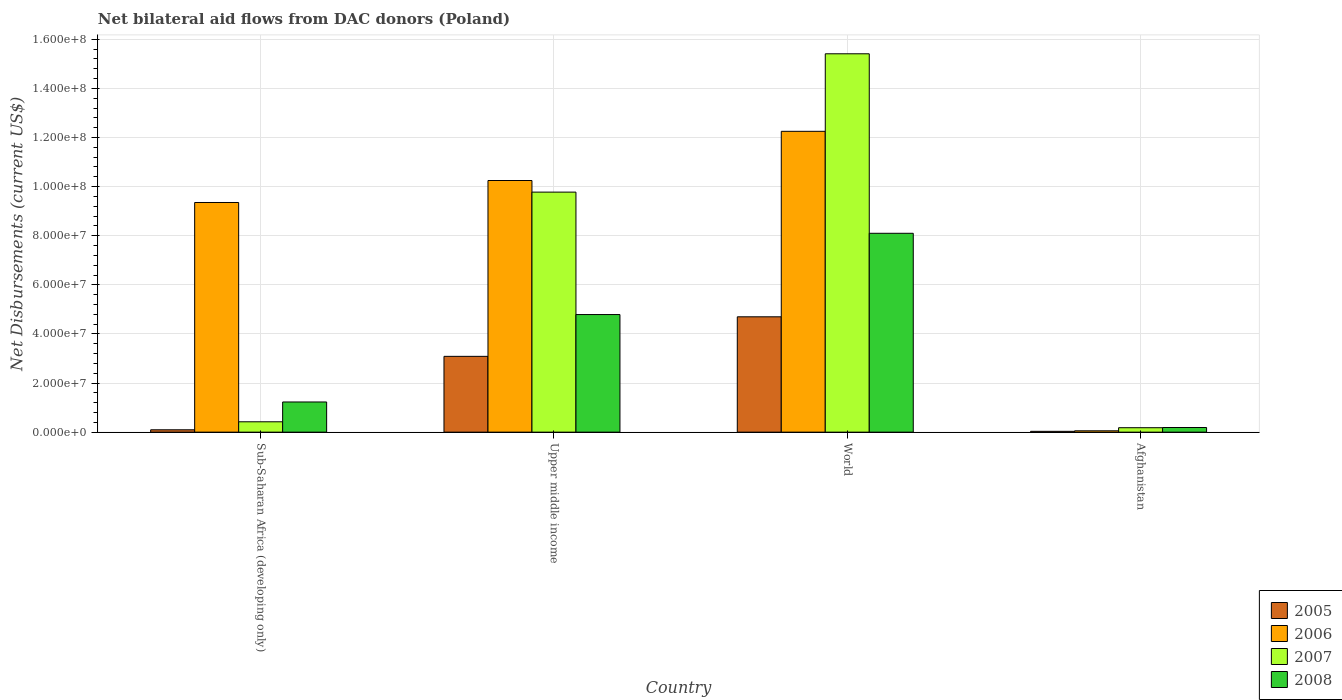How many different coloured bars are there?
Provide a short and direct response. 4. How many groups of bars are there?
Give a very brief answer. 4. Are the number of bars per tick equal to the number of legend labels?
Your response must be concise. Yes. Are the number of bars on each tick of the X-axis equal?
Ensure brevity in your answer.  Yes. What is the label of the 2nd group of bars from the left?
Offer a very short reply. Upper middle income. In how many cases, is the number of bars for a given country not equal to the number of legend labels?
Provide a succinct answer. 0. What is the net bilateral aid flows in 2008 in Afghanistan?
Give a very brief answer. 1.89e+06. Across all countries, what is the maximum net bilateral aid flows in 2008?
Offer a very short reply. 8.10e+07. Across all countries, what is the minimum net bilateral aid flows in 2007?
Your answer should be very brief. 1.81e+06. In which country was the net bilateral aid flows in 2007 minimum?
Keep it short and to the point. Afghanistan. What is the total net bilateral aid flows in 2005 in the graph?
Your answer should be compact. 7.91e+07. What is the difference between the net bilateral aid flows in 2007 in Upper middle income and that in World?
Keep it short and to the point. -5.63e+07. What is the difference between the net bilateral aid flows in 2008 in Upper middle income and the net bilateral aid flows in 2006 in Sub-Saharan Africa (developing only)?
Offer a terse response. -4.56e+07. What is the average net bilateral aid flows in 2008 per country?
Offer a very short reply. 3.58e+07. What is the difference between the net bilateral aid flows of/in 2005 and net bilateral aid flows of/in 2007 in Upper middle income?
Give a very brief answer. -6.69e+07. What is the ratio of the net bilateral aid flows in 2006 in Sub-Saharan Africa (developing only) to that in Upper middle income?
Keep it short and to the point. 0.91. Is the difference between the net bilateral aid flows in 2005 in Sub-Saharan Africa (developing only) and Upper middle income greater than the difference between the net bilateral aid flows in 2007 in Sub-Saharan Africa (developing only) and Upper middle income?
Offer a very short reply. Yes. What is the difference between the highest and the second highest net bilateral aid flows in 2008?
Make the answer very short. 3.31e+07. What is the difference between the highest and the lowest net bilateral aid flows in 2007?
Your answer should be very brief. 1.52e+08. Is the sum of the net bilateral aid flows in 2005 in Upper middle income and World greater than the maximum net bilateral aid flows in 2008 across all countries?
Give a very brief answer. No. What does the 3rd bar from the right in Sub-Saharan Africa (developing only) represents?
Your answer should be very brief. 2006. Is it the case that in every country, the sum of the net bilateral aid flows in 2007 and net bilateral aid flows in 2006 is greater than the net bilateral aid flows in 2008?
Offer a terse response. Yes. Are all the bars in the graph horizontal?
Your response must be concise. No. What is the difference between two consecutive major ticks on the Y-axis?
Make the answer very short. 2.00e+07. Are the values on the major ticks of Y-axis written in scientific E-notation?
Give a very brief answer. Yes. Does the graph contain grids?
Your answer should be compact. Yes. Where does the legend appear in the graph?
Give a very brief answer. Bottom right. How many legend labels are there?
Your answer should be very brief. 4. What is the title of the graph?
Ensure brevity in your answer.  Net bilateral aid flows from DAC donors (Poland). Does "1984" appear as one of the legend labels in the graph?
Provide a succinct answer. No. What is the label or title of the Y-axis?
Offer a very short reply. Net Disbursements (current US$). What is the Net Disbursements (current US$) in 2005 in Sub-Saharan Africa (developing only)?
Ensure brevity in your answer.  9.60e+05. What is the Net Disbursements (current US$) of 2006 in Sub-Saharan Africa (developing only)?
Offer a very short reply. 9.35e+07. What is the Net Disbursements (current US$) in 2007 in Sub-Saharan Africa (developing only)?
Your answer should be compact. 4.22e+06. What is the Net Disbursements (current US$) in 2008 in Sub-Saharan Africa (developing only)?
Offer a terse response. 1.23e+07. What is the Net Disbursements (current US$) of 2005 in Upper middle income?
Provide a short and direct response. 3.09e+07. What is the Net Disbursements (current US$) of 2006 in Upper middle income?
Make the answer very short. 1.02e+08. What is the Net Disbursements (current US$) in 2007 in Upper middle income?
Provide a succinct answer. 9.78e+07. What is the Net Disbursements (current US$) in 2008 in Upper middle income?
Provide a succinct answer. 4.79e+07. What is the Net Disbursements (current US$) in 2005 in World?
Your answer should be very brief. 4.70e+07. What is the Net Disbursements (current US$) in 2006 in World?
Give a very brief answer. 1.23e+08. What is the Net Disbursements (current US$) of 2007 in World?
Your answer should be very brief. 1.54e+08. What is the Net Disbursements (current US$) of 2008 in World?
Offer a terse response. 8.10e+07. What is the Net Disbursements (current US$) in 2007 in Afghanistan?
Offer a very short reply. 1.81e+06. What is the Net Disbursements (current US$) of 2008 in Afghanistan?
Make the answer very short. 1.89e+06. Across all countries, what is the maximum Net Disbursements (current US$) in 2005?
Make the answer very short. 4.70e+07. Across all countries, what is the maximum Net Disbursements (current US$) of 2006?
Keep it short and to the point. 1.23e+08. Across all countries, what is the maximum Net Disbursements (current US$) in 2007?
Your answer should be very brief. 1.54e+08. Across all countries, what is the maximum Net Disbursements (current US$) in 2008?
Provide a succinct answer. 8.10e+07. Across all countries, what is the minimum Net Disbursements (current US$) of 2005?
Your answer should be compact. 3.30e+05. Across all countries, what is the minimum Net Disbursements (current US$) in 2006?
Provide a succinct answer. 5.50e+05. Across all countries, what is the minimum Net Disbursements (current US$) in 2007?
Offer a terse response. 1.81e+06. Across all countries, what is the minimum Net Disbursements (current US$) of 2008?
Provide a short and direct response. 1.89e+06. What is the total Net Disbursements (current US$) of 2005 in the graph?
Provide a short and direct response. 7.91e+07. What is the total Net Disbursements (current US$) in 2006 in the graph?
Provide a short and direct response. 3.19e+08. What is the total Net Disbursements (current US$) in 2007 in the graph?
Your answer should be very brief. 2.58e+08. What is the total Net Disbursements (current US$) in 2008 in the graph?
Offer a terse response. 1.43e+08. What is the difference between the Net Disbursements (current US$) of 2005 in Sub-Saharan Africa (developing only) and that in Upper middle income?
Your answer should be very brief. -2.99e+07. What is the difference between the Net Disbursements (current US$) in 2006 in Sub-Saharan Africa (developing only) and that in Upper middle income?
Offer a very short reply. -8.96e+06. What is the difference between the Net Disbursements (current US$) of 2007 in Sub-Saharan Africa (developing only) and that in Upper middle income?
Your response must be concise. -9.36e+07. What is the difference between the Net Disbursements (current US$) of 2008 in Sub-Saharan Africa (developing only) and that in Upper middle income?
Give a very brief answer. -3.56e+07. What is the difference between the Net Disbursements (current US$) in 2005 in Sub-Saharan Africa (developing only) and that in World?
Give a very brief answer. -4.60e+07. What is the difference between the Net Disbursements (current US$) of 2006 in Sub-Saharan Africa (developing only) and that in World?
Provide a succinct answer. -2.90e+07. What is the difference between the Net Disbursements (current US$) in 2007 in Sub-Saharan Africa (developing only) and that in World?
Provide a short and direct response. -1.50e+08. What is the difference between the Net Disbursements (current US$) in 2008 in Sub-Saharan Africa (developing only) and that in World?
Keep it short and to the point. -6.87e+07. What is the difference between the Net Disbursements (current US$) of 2005 in Sub-Saharan Africa (developing only) and that in Afghanistan?
Offer a very short reply. 6.30e+05. What is the difference between the Net Disbursements (current US$) in 2006 in Sub-Saharan Africa (developing only) and that in Afghanistan?
Your response must be concise. 9.30e+07. What is the difference between the Net Disbursements (current US$) of 2007 in Sub-Saharan Africa (developing only) and that in Afghanistan?
Give a very brief answer. 2.41e+06. What is the difference between the Net Disbursements (current US$) of 2008 in Sub-Saharan Africa (developing only) and that in Afghanistan?
Offer a very short reply. 1.04e+07. What is the difference between the Net Disbursements (current US$) of 2005 in Upper middle income and that in World?
Offer a terse response. -1.61e+07. What is the difference between the Net Disbursements (current US$) in 2006 in Upper middle income and that in World?
Give a very brief answer. -2.00e+07. What is the difference between the Net Disbursements (current US$) of 2007 in Upper middle income and that in World?
Make the answer very short. -5.63e+07. What is the difference between the Net Disbursements (current US$) of 2008 in Upper middle income and that in World?
Keep it short and to the point. -3.31e+07. What is the difference between the Net Disbursements (current US$) of 2005 in Upper middle income and that in Afghanistan?
Provide a short and direct response. 3.05e+07. What is the difference between the Net Disbursements (current US$) of 2006 in Upper middle income and that in Afghanistan?
Ensure brevity in your answer.  1.02e+08. What is the difference between the Net Disbursements (current US$) of 2007 in Upper middle income and that in Afghanistan?
Offer a very short reply. 9.60e+07. What is the difference between the Net Disbursements (current US$) of 2008 in Upper middle income and that in Afghanistan?
Offer a terse response. 4.60e+07. What is the difference between the Net Disbursements (current US$) in 2005 in World and that in Afghanistan?
Your response must be concise. 4.66e+07. What is the difference between the Net Disbursements (current US$) in 2006 in World and that in Afghanistan?
Make the answer very short. 1.22e+08. What is the difference between the Net Disbursements (current US$) of 2007 in World and that in Afghanistan?
Your answer should be very brief. 1.52e+08. What is the difference between the Net Disbursements (current US$) in 2008 in World and that in Afghanistan?
Provide a short and direct response. 7.91e+07. What is the difference between the Net Disbursements (current US$) of 2005 in Sub-Saharan Africa (developing only) and the Net Disbursements (current US$) of 2006 in Upper middle income?
Make the answer very short. -1.02e+08. What is the difference between the Net Disbursements (current US$) of 2005 in Sub-Saharan Africa (developing only) and the Net Disbursements (current US$) of 2007 in Upper middle income?
Offer a terse response. -9.68e+07. What is the difference between the Net Disbursements (current US$) of 2005 in Sub-Saharan Africa (developing only) and the Net Disbursements (current US$) of 2008 in Upper middle income?
Make the answer very short. -4.69e+07. What is the difference between the Net Disbursements (current US$) in 2006 in Sub-Saharan Africa (developing only) and the Net Disbursements (current US$) in 2007 in Upper middle income?
Provide a succinct answer. -4.23e+06. What is the difference between the Net Disbursements (current US$) of 2006 in Sub-Saharan Africa (developing only) and the Net Disbursements (current US$) of 2008 in Upper middle income?
Ensure brevity in your answer.  4.56e+07. What is the difference between the Net Disbursements (current US$) in 2007 in Sub-Saharan Africa (developing only) and the Net Disbursements (current US$) in 2008 in Upper middle income?
Make the answer very short. -4.37e+07. What is the difference between the Net Disbursements (current US$) of 2005 in Sub-Saharan Africa (developing only) and the Net Disbursements (current US$) of 2006 in World?
Your response must be concise. -1.22e+08. What is the difference between the Net Disbursements (current US$) of 2005 in Sub-Saharan Africa (developing only) and the Net Disbursements (current US$) of 2007 in World?
Give a very brief answer. -1.53e+08. What is the difference between the Net Disbursements (current US$) in 2005 in Sub-Saharan Africa (developing only) and the Net Disbursements (current US$) in 2008 in World?
Provide a short and direct response. -8.00e+07. What is the difference between the Net Disbursements (current US$) of 2006 in Sub-Saharan Africa (developing only) and the Net Disbursements (current US$) of 2007 in World?
Your response must be concise. -6.06e+07. What is the difference between the Net Disbursements (current US$) of 2006 in Sub-Saharan Africa (developing only) and the Net Disbursements (current US$) of 2008 in World?
Provide a short and direct response. 1.25e+07. What is the difference between the Net Disbursements (current US$) of 2007 in Sub-Saharan Africa (developing only) and the Net Disbursements (current US$) of 2008 in World?
Offer a very short reply. -7.68e+07. What is the difference between the Net Disbursements (current US$) of 2005 in Sub-Saharan Africa (developing only) and the Net Disbursements (current US$) of 2006 in Afghanistan?
Make the answer very short. 4.10e+05. What is the difference between the Net Disbursements (current US$) in 2005 in Sub-Saharan Africa (developing only) and the Net Disbursements (current US$) in 2007 in Afghanistan?
Give a very brief answer. -8.50e+05. What is the difference between the Net Disbursements (current US$) in 2005 in Sub-Saharan Africa (developing only) and the Net Disbursements (current US$) in 2008 in Afghanistan?
Make the answer very short. -9.30e+05. What is the difference between the Net Disbursements (current US$) in 2006 in Sub-Saharan Africa (developing only) and the Net Disbursements (current US$) in 2007 in Afghanistan?
Give a very brief answer. 9.17e+07. What is the difference between the Net Disbursements (current US$) in 2006 in Sub-Saharan Africa (developing only) and the Net Disbursements (current US$) in 2008 in Afghanistan?
Offer a terse response. 9.16e+07. What is the difference between the Net Disbursements (current US$) of 2007 in Sub-Saharan Africa (developing only) and the Net Disbursements (current US$) of 2008 in Afghanistan?
Your answer should be very brief. 2.33e+06. What is the difference between the Net Disbursements (current US$) in 2005 in Upper middle income and the Net Disbursements (current US$) in 2006 in World?
Provide a succinct answer. -9.17e+07. What is the difference between the Net Disbursements (current US$) of 2005 in Upper middle income and the Net Disbursements (current US$) of 2007 in World?
Offer a very short reply. -1.23e+08. What is the difference between the Net Disbursements (current US$) in 2005 in Upper middle income and the Net Disbursements (current US$) in 2008 in World?
Provide a succinct answer. -5.01e+07. What is the difference between the Net Disbursements (current US$) of 2006 in Upper middle income and the Net Disbursements (current US$) of 2007 in World?
Keep it short and to the point. -5.16e+07. What is the difference between the Net Disbursements (current US$) of 2006 in Upper middle income and the Net Disbursements (current US$) of 2008 in World?
Ensure brevity in your answer.  2.15e+07. What is the difference between the Net Disbursements (current US$) in 2007 in Upper middle income and the Net Disbursements (current US$) in 2008 in World?
Make the answer very short. 1.68e+07. What is the difference between the Net Disbursements (current US$) in 2005 in Upper middle income and the Net Disbursements (current US$) in 2006 in Afghanistan?
Ensure brevity in your answer.  3.03e+07. What is the difference between the Net Disbursements (current US$) of 2005 in Upper middle income and the Net Disbursements (current US$) of 2007 in Afghanistan?
Offer a terse response. 2.91e+07. What is the difference between the Net Disbursements (current US$) of 2005 in Upper middle income and the Net Disbursements (current US$) of 2008 in Afghanistan?
Make the answer very short. 2.90e+07. What is the difference between the Net Disbursements (current US$) of 2006 in Upper middle income and the Net Disbursements (current US$) of 2007 in Afghanistan?
Ensure brevity in your answer.  1.01e+08. What is the difference between the Net Disbursements (current US$) in 2006 in Upper middle income and the Net Disbursements (current US$) in 2008 in Afghanistan?
Offer a terse response. 1.01e+08. What is the difference between the Net Disbursements (current US$) of 2007 in Upper middle income and the Net Disbursements (current US$) of 2008 in Afghanistan?
Offer a terse response. 9.59e+07. What is the difference between the Net Disbursements (current US$) of 2005 in World and the Net Disbursements (current US$) of 2006 in Afghanistan?
Keep it short and to the point. 4.64e+07. What is the difference between the Net Disbursements (current US$) of 2005 in World and the Net Disbursements (current US$) of 2007 in Afghanistan?
Offer a terse response. 4.52e+07. What is the difference between the Net Disbursements (current US$) in 2005 in World and the Net Disbursements (current US$) in 2008 in Afghanistan?
Give a very brief answer. 4.51e+07. What is the difference between the Net Disbursements (current US$) of 2006 in World and the Net Disbursements (current US$) of 2007 in Afghanistan?
Keep it short and to the point. 1.21e+08. What is the difference between the Net Disbursements (current US$) of 2006 in World and the Net Disbursements (current US$) of 2008 in Afghanistan?
Give a very brief answer. 1.21e+08. What is the difference between the Net Disbursements (current US$) of 2007 in World and the Net Disbursements (current US$) of 2008 in Afghanistan?
Provide a succinct answer. 1.52e+08. What is the average Net Disbursements (current US$) of 2005 per country?
Keep it short and to the point. 1.98e+07. What is the average Net Disbursements (current US$) of 2006 per country?
Keep it short and to the point. 7.98e+07. What is the average Net Disbursements (current US$) in 2007 per country?
Offer a very short reply. 6.45e+07. What is the average Net Disbursements (current US$) of 2008 per country?
Offer a very short reply. 3.58e+07. What is the difference between the Net Disbursements (current US$) of 2005 and Net Disbursements (current US$) of 2006 in Sub-Saharan Africa (developing only)?
Offer a terse response. -9.26e+07. What is the difference between the Net Disbursements (current US$) of 2005 and Net Disbursements (current US$) of 2007 in Sub-Saharan Africa (developing only)?
Your answer should be very brief. -3.26e+06. What is the difference between the Net Disbursements (current US$) of 2005 and Net Disbursements (current US$) of 2008 in Sub-Saharan Africa (developing only)?
Provide a succinct answer. -1.13e+07. What is the difference between the Net Disbursements (current US$) in 2006 and Net Disbursements (current US$) in 2007 in Sub-Saharan Africa (developing only)?
Provide a short and direct response. 8.93e+07. What is the difference between the Net Disbursements (current US$) of 2006 and Net Disbursements (current US$) of 2008 in Sub-Saharan Africa (developing only)?
Provide a succinct answer. 8.12e+07. What is the difference between the Net Disbursements (current US$) in 2007 and Net Disbursements (current US$) in 2008 in Sub-Saharan Africa (developing only)?
Give a very brief answer. -8.07e+06. What is the difference between the Net Disbursements (current US$) of 2005 and Net Disbursements (current US$) of 2006 in Upper middle income?
Offer a terse response. -7.16e+07. What is the difference between the Net Disbursements (current US$) of 2005 and Net Disbursements (current US$) of 2007 in Upper middle income?
Make the answer very short. -6.69e+07. What is the difference between the Net Disbursements (current US$) in 2005 and Net Disbursements (current US$) in 2008 in Upper middle income?
Offer a very short reply. -1.70e+07. What is the difference between the Net Disbursements (current US$) of 2006 and Net Disbursements (current US$) of 2007 in Upper middle income?
Your answer should be compact. 4.73e+06. What is the difference between the Net Disbursements (current US$) of 2006 and Net Disbursements (current US$) of 2008 in Upper middle income?
Your answer should be very brief. 5.46e+07. What is the difference between the Net Disbursements (current US$) in 2007 and Net Disbursements (current US$) in 2008 in Upper middle income?
Your response must be concise. 4.99e+07. What is the difference between the Net Disbursements (current US$) in 2005 and Net Disbursements (current US$) in 2006 in World?
Make the answer very short. -7.56e+07. What is the difference between the Net Disbursements (current US$) in 2005 and Net Disbursements (current US$) in 2007 in World?
Provide a short and direct response. -1.07e+08. What is the difference between the Net Disbursements (current US$) in 2005 and Net Disbursements (current US$) in 2008 in World?
Your answer should be compact. -3.40e+07. What is the difference between the Net Disbursements (current US$) in 2006 and Net Disbursements (current US$) in 2007 in World?
Your response must be concise. -3.16e+07. What is the difference between the Net Disbursements (current US$) of 2006 and Net Disbursements (current US$) of 2008 in World?
Your answer should be compact. 4.15e+07. What is the difference between the Net Disbursements (current US$) of 2007 and Net Disbursements (current US$) of 2008 in World?
Give a very brief answer. 7.31e+07. What is the difference between the Net Disbursements (current US$) of 2005 and Net Disbursements (current US$) of 2007 in Afghanistan?
Your answer should be compact. -1.48e+06. What is the difference between the Net Disbursements (current US$) in 2005 and Net Disbursements (current US$) in 2008 in Afghanistan?
Your answer should be compact. -1.56e+06. What is the difference between the Net Disbursements (current US$) of 2006 and Net Disbursements (current US$) of 2007 in Afghanistan?
Offer a terse response. -1.26e+06. What is the difference between the Net Disbursements (current US$) of 2006 and Net Disbursements (current US$) of 2008 in Afghanistan?
Provide a short and direct response. -1.34e+06. What is the ratio of the Net Disbursements (current US$) of 2005 in Sub-Saharan Africa (developing only) to that in Upper middle income?
Keep it short and to the point. 0.03. What is the ratio of the Net Disbursements (current US$) of 2006 in Sub-Saharan Africa (developing only) to that in Upper middle income?
Provide a succinct answer. 0.91. What is the ratio of the Net Disbursements (current US$) in 2007 in Sub-Saharan Africa (developing only) to that in Upper middle income?
Your response must be concise. 0.04. What is the ratio of the Net Disbursements (current US$) in 2008 in Sub-Saharan Africa (developing only) to that in Upper middle income?
Your response must be concise. 0.26. What is the ratio of the Net Disbursements (current US$) of 2005 in Sub-Saharan Africa (developing only) to that in World?
Give a very brief answer. 0.02. What is the ratio of the Net Disbursements (current US$) of 2006 in Sub-Saharan Africa (developing only) to that in World?
Ensure brevity in your answer.  0.76. What is the ratio of the Net Disbursements (current US$) in 2007 in Sub-Saharan Africa (developing only) to that in World?
Your answer should be very brief. 0.03. What is the ratio of the Net Disbursements (current US$) of 2008 in Sub-Saharan Africa (developing only) to that in World?
Provide a short and direct response. 0.15. What is the ratio of the Net Disbursements (current US$) of 2005 in Sub-Saharan Africa (developing only) to that in Afghanistan?
Offer a terse response. 2.91. What is the ratio of the Net Disbursements (current US$) in 2006 in Sub-Saharan Africa (developing only) to that in Afghanistan?
Your answer should be very brief. 170.07. What is the ratio of the Net Disbursements (current US$) in 2007 in Sub-Saharan Africa (developing only) to that in Afghanistan?
Your answer should be very brief. 2.33. What is the ratio of the Net Disbursements (current US$) of 2008 in Sub-Saharan Africa (developing only) to that in Afghanistan?
Your answer should be compact. 6.5. What is the ratio of the Net Disbursements (current US$) of 2005 in Upper middle income to that in World?
Keep it short and to the point. 0.66. What is the ratio of the Net Disbursements (current US$) in 2006 in Upper middle income to that in World?
Make the answer very short. 0.84. What is the ratio of the Net Disbursements (current US$) in 2007 in Upper middle income to that in World?
Ensure brevity in your answer.  0.63. What is the ratio of the Net Disbursements (current US$) in 2008 in Upper middle income to that in World?
Make the answer very short. 0.59. What is the ratio of the Net Disbursements (current US$) of 2005 in Upper middle income to that in Afghanistan?
Ensure brevity in your answer.  93.55. What is the ratio of the Net Disbursements (current US$) of 2006 in Upper middle income to that in Afghanistan?
Your answer should be very brief. 186.36. What is the ratio of the Net Disbursements (current US$) in 2007 in Upper middle income to that in Afghanistan?
Give a very brief answer. 54.02. What is the ratio of the Net Disbursements (current US$) in 2008 in Upper middle income to that in Afghanistan?
Offer a very short reply. 25.34. What is the ratio of the Net Disbursements (current US$) in 2005 in World to that in Afghanistan?
Your answer should be very brief. 142.36. What is the ratio of the Net Disbursements (current US$) of 2006 in World to that in Afghanistan?
Provide a succinct answer. 222.78. What is the ratio of the Net Disbursements (current US$) in 2007 in World to that in Afghanistan?
Offer a very short reply. 85.14. What is the ratio of the Net Disbursements (current US$) in 2008 in World to that in Afghanistan?
Offer a very short reply. 42.86. What is the difference between the highest and the second highest Net Disbursements (current US$) of 2005?
Offer a very short reply. 1.61e+07. What is the difference between the highest and the second highest Net Disbursements (current US$) of 2006?
Offer a very short reply. 2.00e+07. What is the difference between the highest and the second highest Net Disbursements (current US$) of 2007?
Your answer should be compact. 5.63e+07. What is the difference between the highest and the second highest Net Disbursements (current US$) of 2008?
Provide a succinct answer. 3.31e+07. What is the difference between the highest and the lowest Net Disbursements (current US$) of 2005?
Your answer should be very brief. 4.66e+07. What is the difference between the highest and the lowest Net Disbursements (current US$) of 2006?
Offer a very short reply. 1.22e+08. What is the difference between the highest and the lowest Net Disbursements (current US$) in 2007?
Ensure brevity in your answer.  1.52e+08. What is the difference between the highest and the lowest Net Disbursements (current US$) in 2008?
Give a very brief answer. 7.91e+07. 